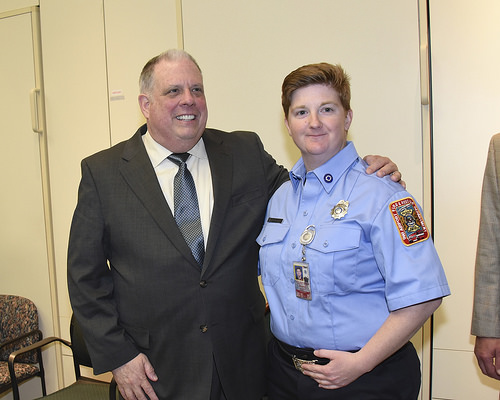<image>
Is there a chair behind the man? Yes. From this viewpoint, the chair is positioned behind the man, with the man partially or fully occluding the chair. 